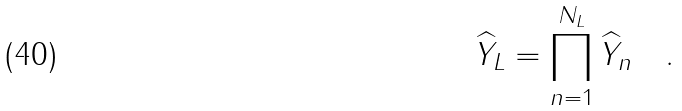Convert formula to latex. <formula><loc_0><loc_0><loc_500><loc_500>\widehat { Y } _ { L } = \prod ^ { N _ { L } } _ { n = 1 } \widehat { Y } _ { n } \quad .</formula> 